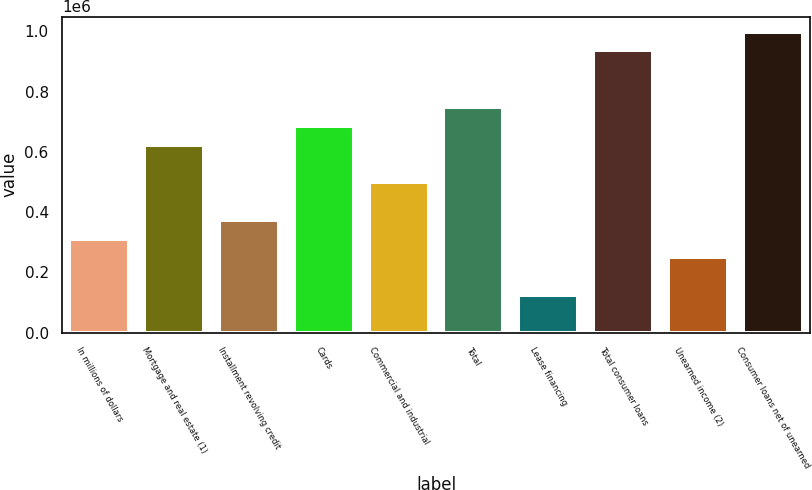Convert chart to OTSL. <chart><loc_0><loc_0><loc_500><loc_500><bar_chart><fcel>In millions of dollars<fcel>Mortgage and real estate (1)<fcel>Installment revolving credit<fcel>Cards<fcel>Commercial and industrial<fcel>Total<fcel>Lease financing<fcel>Total consumer loans<fcel>Unearned income (2)<fcel>Consumer loans net of unearned<nl><fcel>312185<fcel>624369<fcel>374622<fcel>686806<fcel>499496<fcel>749242<fcel>124875<fcel>936553<fcel>249749<fcel>998989<nl></chart> 